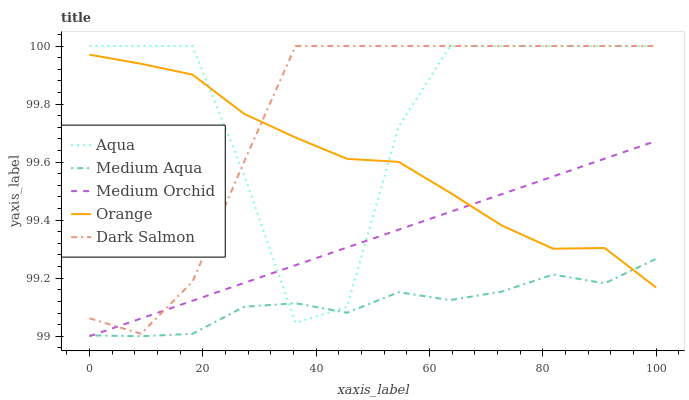Does Medium Aqua have the minimum area under the curve?
Answer yes or no. Yes. Does Aqua have the maximum area under the curve?
Answer yes or no. Yes. Does Medium Orchid have the minimum area under the curve?
Answer yes or no. No. Does Medium Orchid have the maximum area under the curve?
Answer yes or no. No. Is Medium Orchid the smoothest?
Answer yes or no. Yes. Is Aqua the roughest?
Answer yes or no. Yes. Is Medium Aqua the smoothest?
Answer yes or no. No. Is Medium Aqua the roughest?
Answer yes or no. No. Does Medium Aqua have the lowest value?
Answer yes or no. Yes. Does Aqua have the lowest value?
Answer yes or no. No. Does Dark Salmon have the highest value?
Answer yes or no. Yes. Does Medium Orchid have the highest value?
Answer yes or no. No. Is Medium Aqua less than Dark Salmon?
Answer yes or no. Yes. Is Dark Salmon greater than Medium Aqua?
Answer yes or no. Yes. Does Medium Aqua intersect Orange?
Answer yes or no. Yes. Is Medium Aqua less than Orange?
Answer yes or no. No. Is Medium Aqua greater than Orange?
Answer yes or no. No. Does Medium Aqua intersect Dark Salmon?
Answer yes or no. No. 